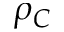Convert formula to latex. <formula><loc_0><loc_0><loc_500><loc_500>\rho _ { C }</formula> 